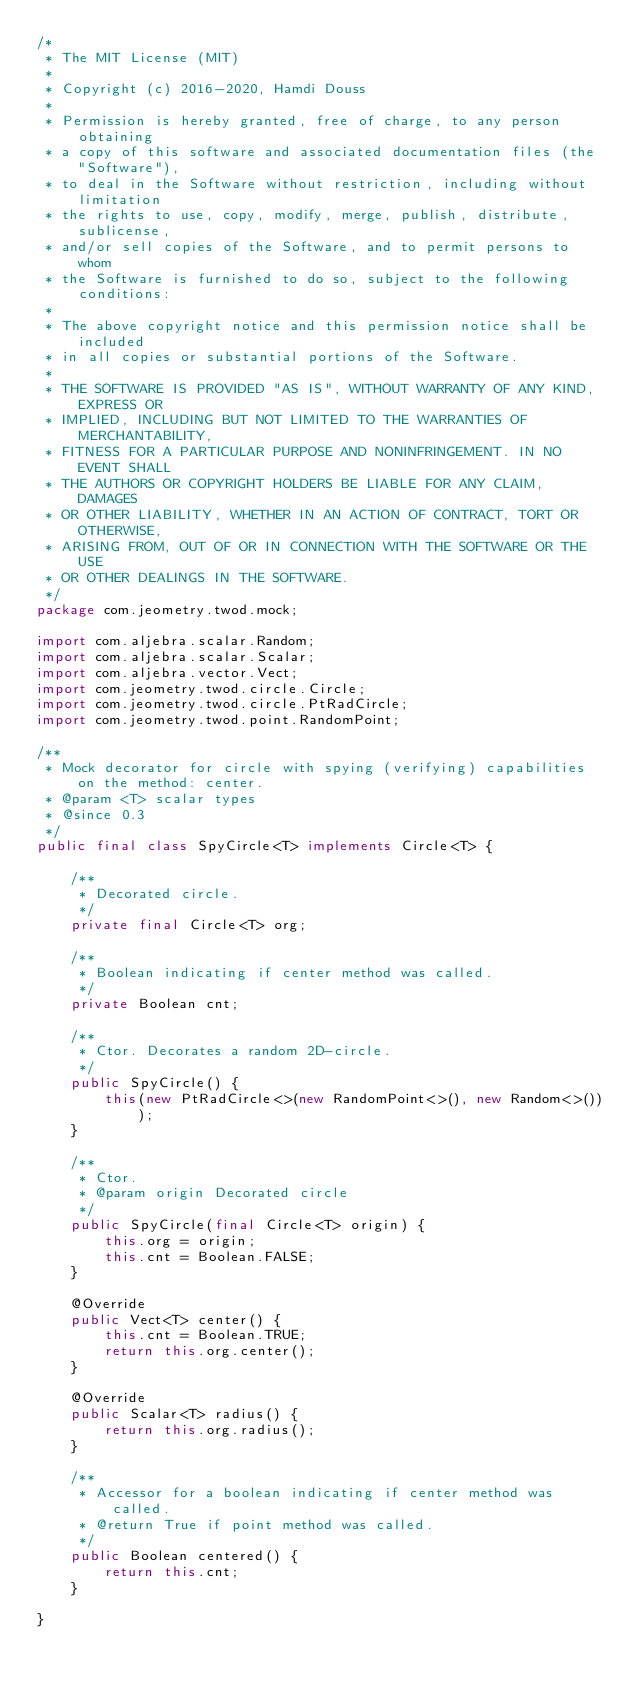Convert code to text. <code><loc_0><loc_0><loc_500><loc_500><_Java_>/*
 * The MIT License (MIT)
 *
 * Copyright (c) 2016-2020, Hamdi Douss
 *
 * Permission is hereby granted, free of charge, to any person obtaining
 * a copy of this software and associated documentation files (the "Software"),
 * to deal in the Software without restriction, including without limitation
 * the rights to use, copy, modify, merge, publish, distribute, sublicense,
 * and/or sell copies of the Software, and to permit persons to whom
 * the Software is furnished to do so, subject to the following conditions:
 *
 * The above copyright notice and this permission notice shall be included
 * in all copies or substantial portions of the Software.
 *
 * THE SOFTWARE IS PROVIDED "AS IS", WITHOUT WARRANTY OF ANY KIND, EXPRESS OR
 * IMPLIED, INCLUDING BUT NOT LIMITED TO THE WARRANTIES OF MERCHANTABILITY,
 * FITNESS FOR A PARTICULAR PURPOSE AND NONINFRINGEMENT. IN NO EVENT SHALL
 * THE AUTHORS OR COPYRIGHT HOLDERS BE LIABLE FOR ANY CLAIM, DAMAGES
 * OR OTHER LIABILITY, WHETHER IN AN ACTION OF CONTRACT, TORT OR OTHERWISE,
 * ARISING FROM, OUT OF OR IN CONNECTION WITH THE SOFTWARE OR THE USE
 * OR OTHER DEALINGS IN THE SOFTWARE.
 */
package com.jeometry.twod.mock;

import com.aljebra.scalar.Random;
import com.aljebra.scalar.Scalar;
import com.aljebra.vector.Vect;
import com.jeometry.twod.circle.Circle;
import com.jeometry.twod.circle.PtRadCircle;
import com.jeometry.twod.point.RandomPoint;

/**
 * Mock decorator for circle with spying (verifying) capabilities on the method: center.
 * @param <T> scalar types
 * @since 0.3
 */
public final class SpyCircle<T> implements Circle<T> {

    /**
     * Decorated circle.
     */
    private final Circle<T> org;

    /**
     * Boolean indicating if center method was called.
     */
    private Boolean cnt;

    /**
     * Ctor. Decorates a random 2D-circle.
     */
    public SpyCircle() {
        this(new PtRadCircle<>(new RandomPoint<>(), new Random<>()));
    }

    /**
     * Ctor.
     * @param origin Decorated circle
     */
    public SpyCircle(final Circle<T> origin) {
        this.org = origin;
        this.cnt = Boolean.FALSE;
    }

    @Override
    public Vect<T> center() {
        this.cnt = Boolean.TRUE;
        return this.org.center();
    }

    @Override
    public Scalar<T> radius() {
        return this.org.radius();
    }

    /**
     * Accessor for a boolean indicating if center method was called.
     * @return True if point method was called.
     */
    public Boolean centered() {
        return this.cnt;
    }

}
</code> 